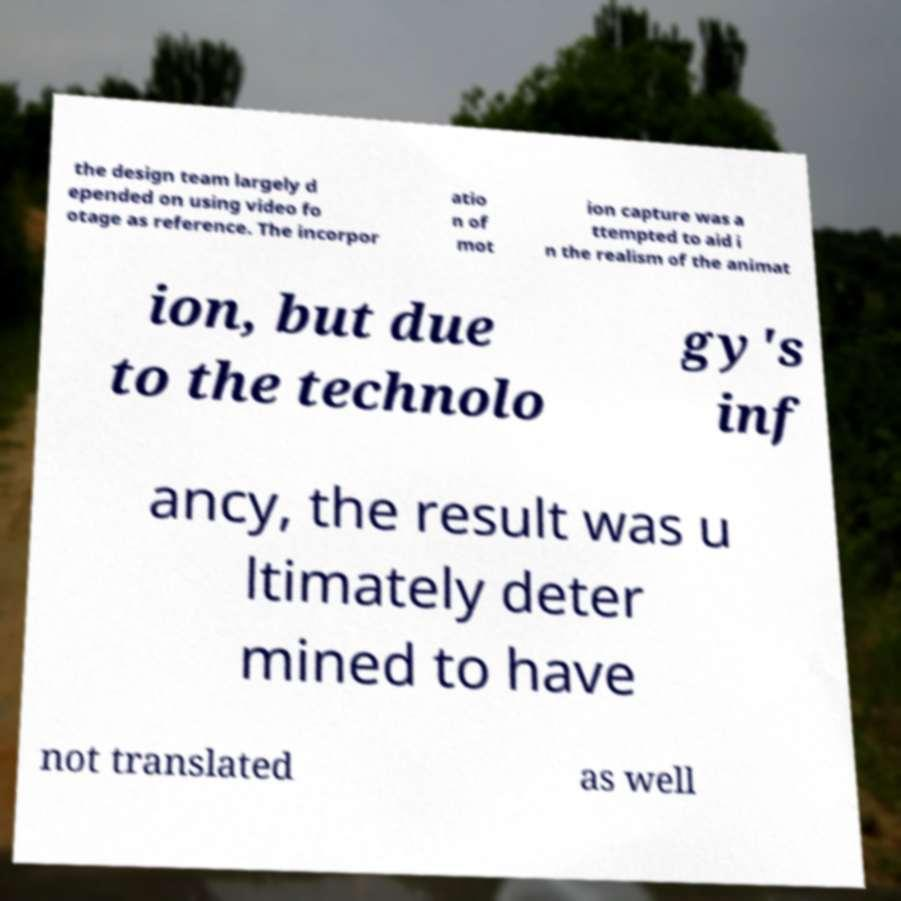Can you read and provide the text displayed in the image?This photo seems to have some interesting text. Can you extract and type it out for me? the design team largely d epended on using video fo otage as reference. The incorpor atio n of mot ion capture was a ttempted to aid i n the realism of the animat ion, but due to the technolo gy's inf ancy, the result was u ltimately deter mined to have not translated as well 